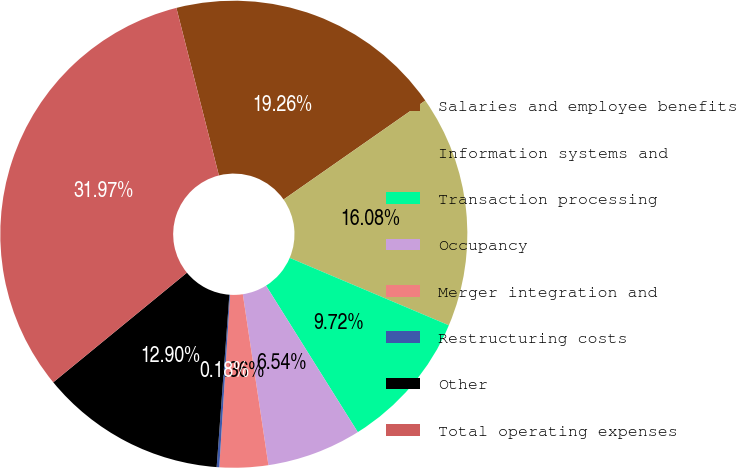Convert chart. <chart><loc_0><loc_0><loc_500><loc_500><pie_chart><fcel>Salaries and employee benefits<fcel>Information systems and<fcel>Transaction processing<fcel>Occupancy<fcel>Merger integration and<fcel>Restructuring costs<fcel>Other<fcel>Total operating expenses<nl><fcel>19.26%<fcel>16.08%<fcel>9.72%<fcel>6.54%<fcel>3.36%<fcel>0.18%<fcel>12.9%<fcel>31.98%<nl></chart> 